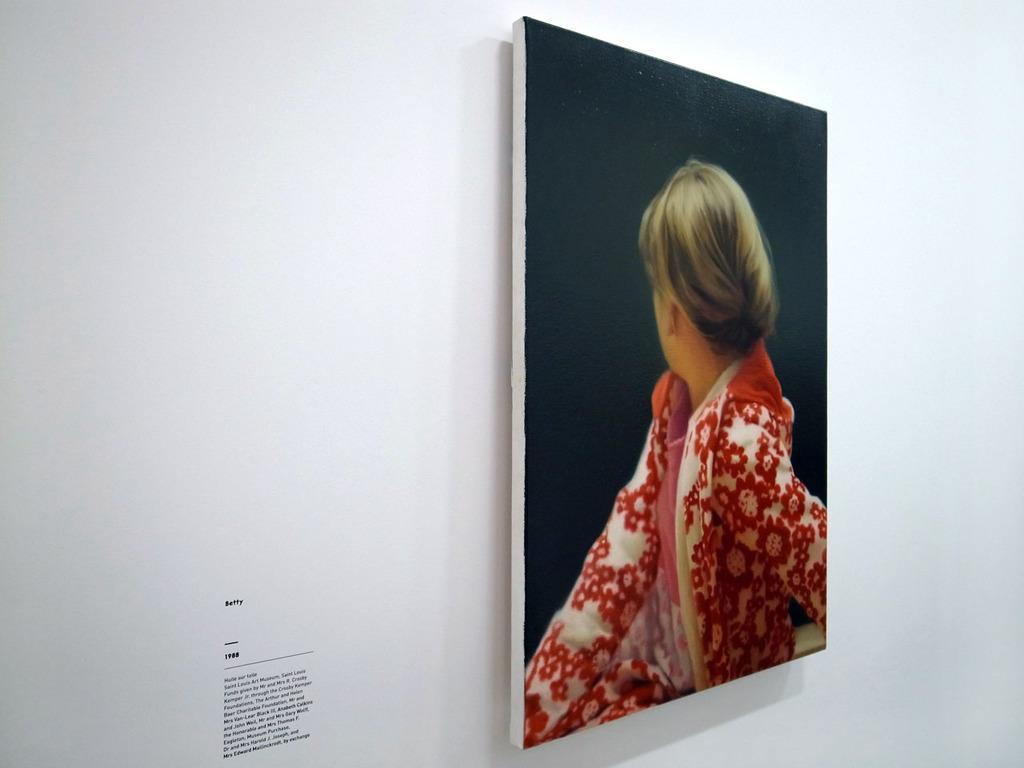In one or two sentences, can you explain what this image depicts? In the image there is a photo attached to a wall and on the left side there is some text on the wall. 